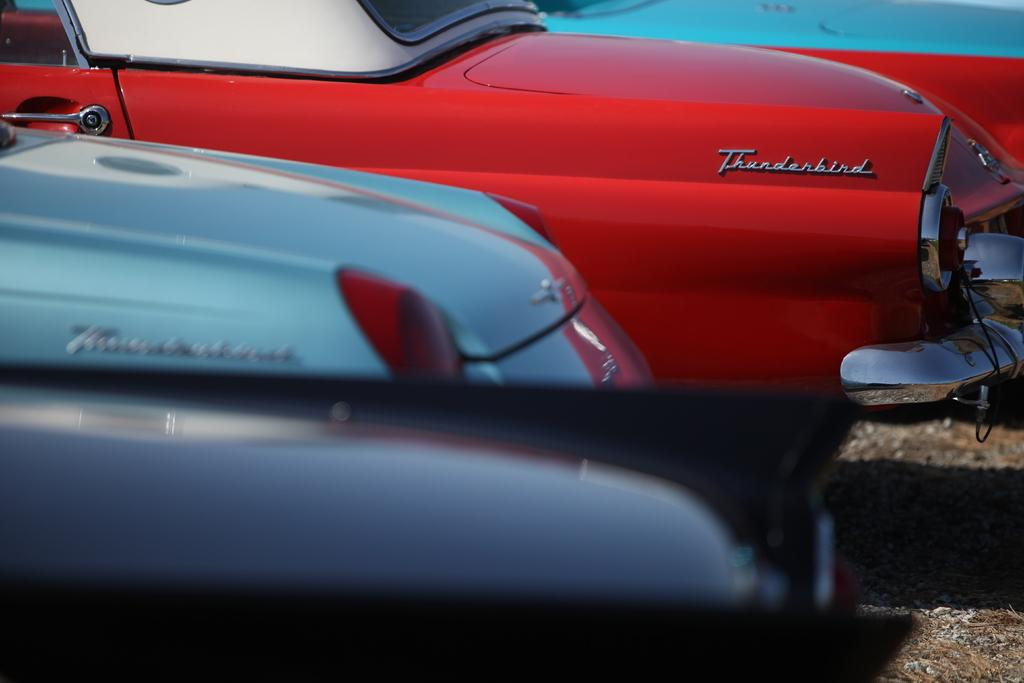What type of vehicles are present in the image? There are cars in the image. Can you describe the appearance of the cars? The cars have different colors and different models. Where is the store located in the image? There is no store present in the image; it features cars with different colors and models. What type of sweater is the driver wearing in the image? There is no driver or sweater visible in the image, as it only shows cars with different colors and models. 